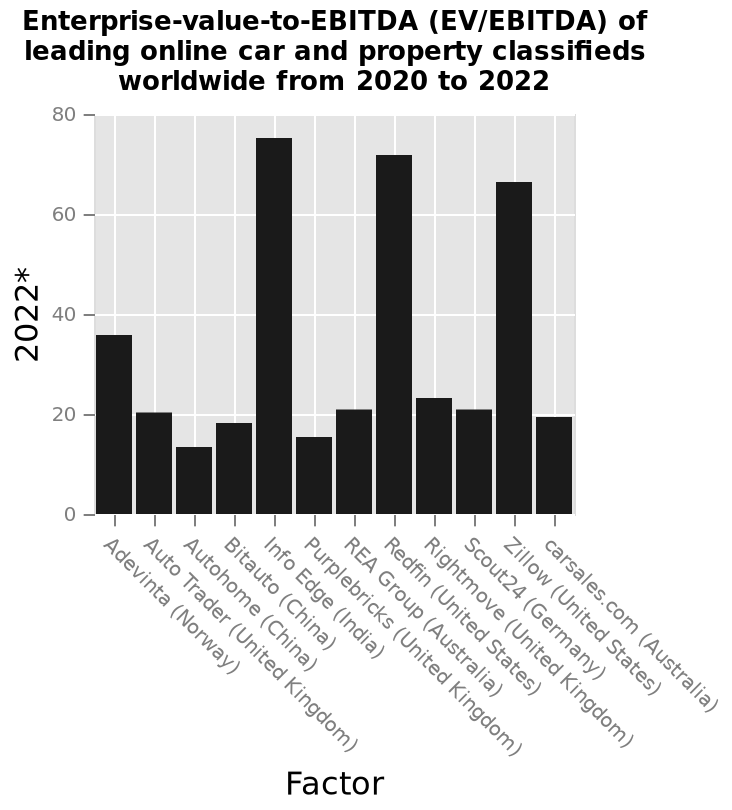<image>
please summary the statistics and relations of the chart Two of the 12 leading online car and property classifieds worldwide showing the highest  EV/EBITDA (between 60 and 80) from 2020 to 2022, are in the USA and one in India. The remaining ones are in the UK, China, Australia and Norway, with the majority showing an EV/EBITDA of around 20 or below, except for Norway which has EV/EBITDA of around 50. Which countries have online car and property classifieds with an EV/EBITDA ratio of around 50?  Norway is the only country among the leading online car and property classifieds that has an EV/EBITDA ratio of around 50. What is the highest value on the y-axis in the bar diagram?  The highest value on the y-axis in the bar diagram is 80. 